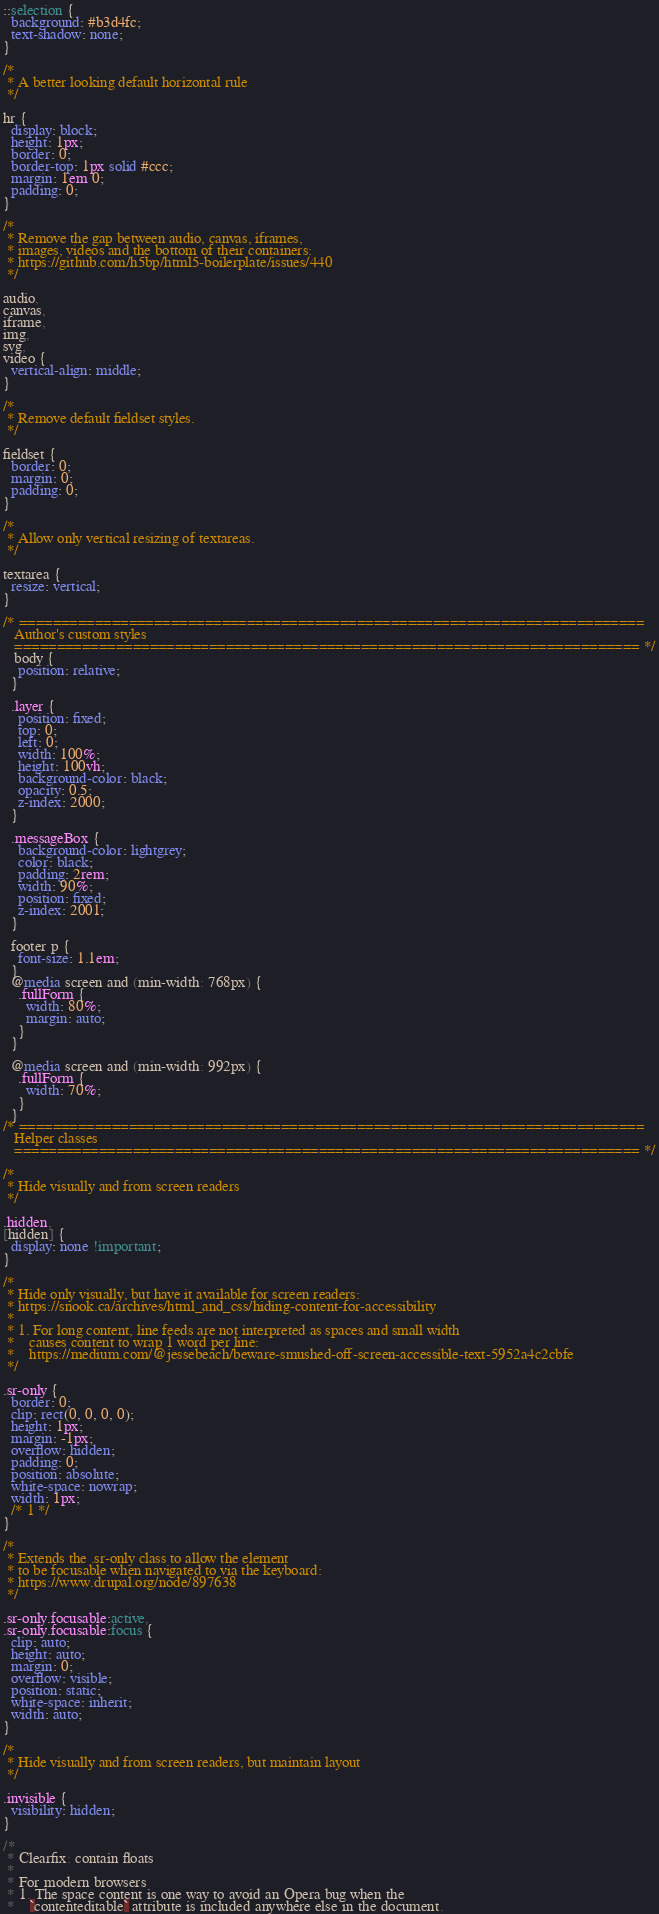Convert code to text. <code><loc_0><loc_0><loc_500><loc_500><_CSS_>
::selection {
  background: #b3d4fc;
  text-shadow: none;
}

/*
 * A better looking default horizontal rule
 */

hr {
  display: block;
  height: 1px;
  border: 0;
  border-top: 1px solid #ccc;
  margin: 1em 0;
  padding: 0;
}

/*
 * Remove the gap between audio, canvas, iframes,
 * images, videos and the bottom of their containers:
 * https://github.com/h5bp/html5-boilerplate/issues/440
 */

audio,
canvas,
iframe,
img,
svg,
video {
  vertical-align: middle;
}

/*
 * Remove default fieldset styles.
 */

fieldset {
  border: 0;
  margin: 0;
  padding: 0;
}

/*
 * Allow only vertical resizing of textareas.
 */

textarea {
  resize: vertical;
}

/* ==========================================================================
   Author's custom styles
   ========================================================================== */
   body {
    position: relative;
  }

  .layer {
    position: fixed;
    top: 0;
    left: 0;
    width: 100%;
    height: 100vh;
    background-color: black;
    opacity: 0.5;
    z-index: 2000;
  }
  
  .messageBox {
    background-color: lightgrey;
    color: black;
    padding: 2rem;
    width: 90%;
    position: fixed;
    z-index: 2001;
  }
  
  footer p {
    font-size: 1.1em;
  }
  @media screen and (min-width: 768px) {
    .fullForm {
      width: 80%;
      margin: auto;
    }
  }
  
  @media screen and (min-width: 992px) {
    .fullForm {
      width: 70%;
    }
  }
/* ==========================================================================
   Helper classes
   ========================================================================== */

/*
 * Hide visually and from screen readers
 */

.hidden,
[hidden] {
  display: none !important;
}

/*
 * Hide only visually, but have it available for screen readers:
 * https://snook.ca/archives/html_and_css/hiding-content-for-accessibility
 *
 * 1. For long content, line feeds are not interpreted as spaces and small width
 *    causes content to wrap 1 word per line:
 *    https://medium.com/@jessebeach/beware-smushed-off-screen-accessible-text-5952a4c2cbfe
 */

.sr-only {
  border: 0;
  clip: rect(0, 0, 0, 0);
  height: 1px;
  margin: -1px;
  overflow: hidden;
  padding: 0;
  position: absolute;
  white-space: nowrap;
  width: 1px;
  /* 1 */
}

/*
 * Extends the .sr-only class to allow the element
 * to be focusable when navigated to via the keyboard:
 * https://www.drupal.org/node/897638
 */

.sr-only.focusable:active,
.sr-only.focusable:focus {
  clip: auto;
  height: auto;
  margin: 0;
  overflow: visible;
  position: static;
  white-space: inherit;
  width: auto;
}

/*
 * Hide visually and from screen readers, but maintain layout
 */

.invisible {
  visibility: hidden;
}

/*
 * Clearfix: contain floats
 *
 * For modern browsers
 * 1. The space content is one way to avoid an Opera bug when the
 *    `contenteditable` attribute is included anywhere else in the document.</code> 